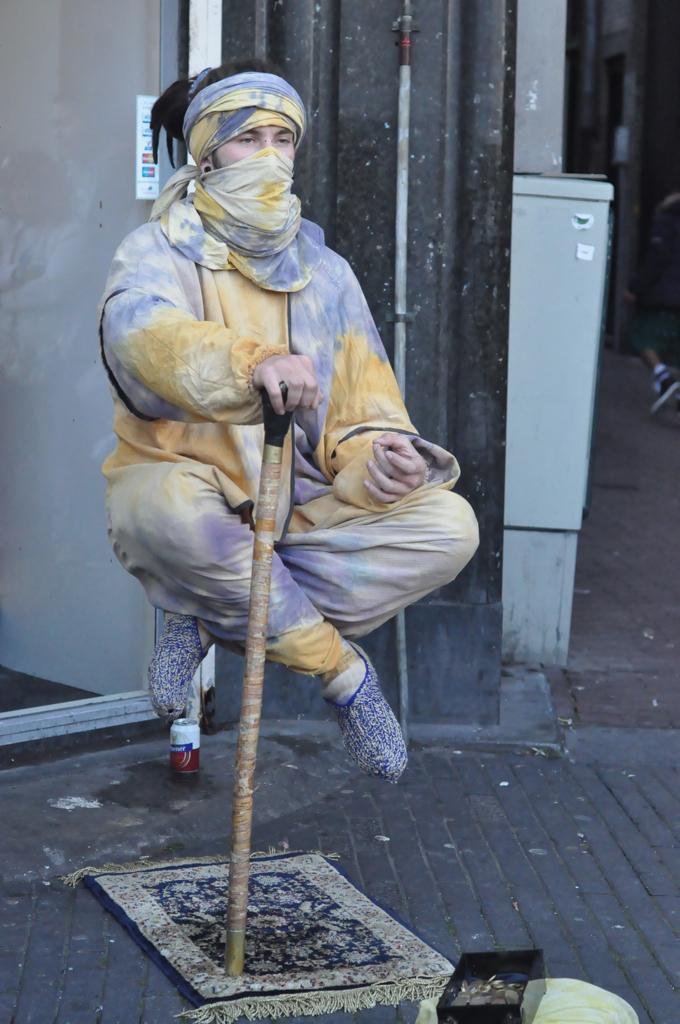Please provide a concise description of this image. In this picture we can see a person in the air and the person is holding a stick. Under the person there is a cloth and some coins in the black box. Behind the person there is a tin, transparent glass and a pipe on the wall. On the right side of the wall, it looks like a person is walking on the walkway. 